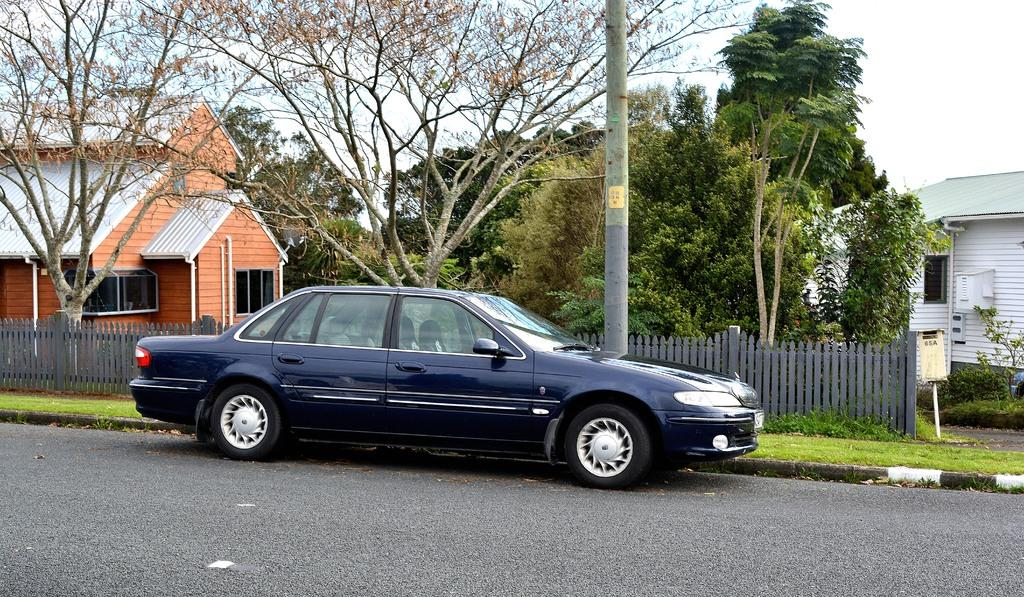What is the main feature of the image? There is a road in the image. What is on the road? A car is present on the road. What is beside the road? There is a wooden fence beside the road. What type of structures can be seen in the image? There are houses in the image. What natural elements are visible in the image? Trees are visible in the image. How would you describe the weather in the image? The sky is clear in the image, suggesting good weather. Can you tell me how many requests are being made by the sofa in the image? There is no sofa present in the image, so it is not possible to determine if any requests are being made. 